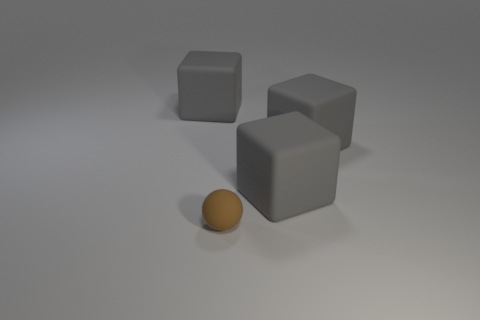Add 4 large gray matte cubes. How many objects exist? 8 Subtract 1 blocks. How many blocks are left? 2 Subtract all cubes. How many objects are left? 1 Subtract all tiny brown objects. Subtract all gray rubber objects. How many objects are left? 0 Add 1 big things. How many big things are left? 4 Add 1 small green blocks. How many small green blocks exist? 1 Subtract 0 gray cylinders. How many objects are left? 4 